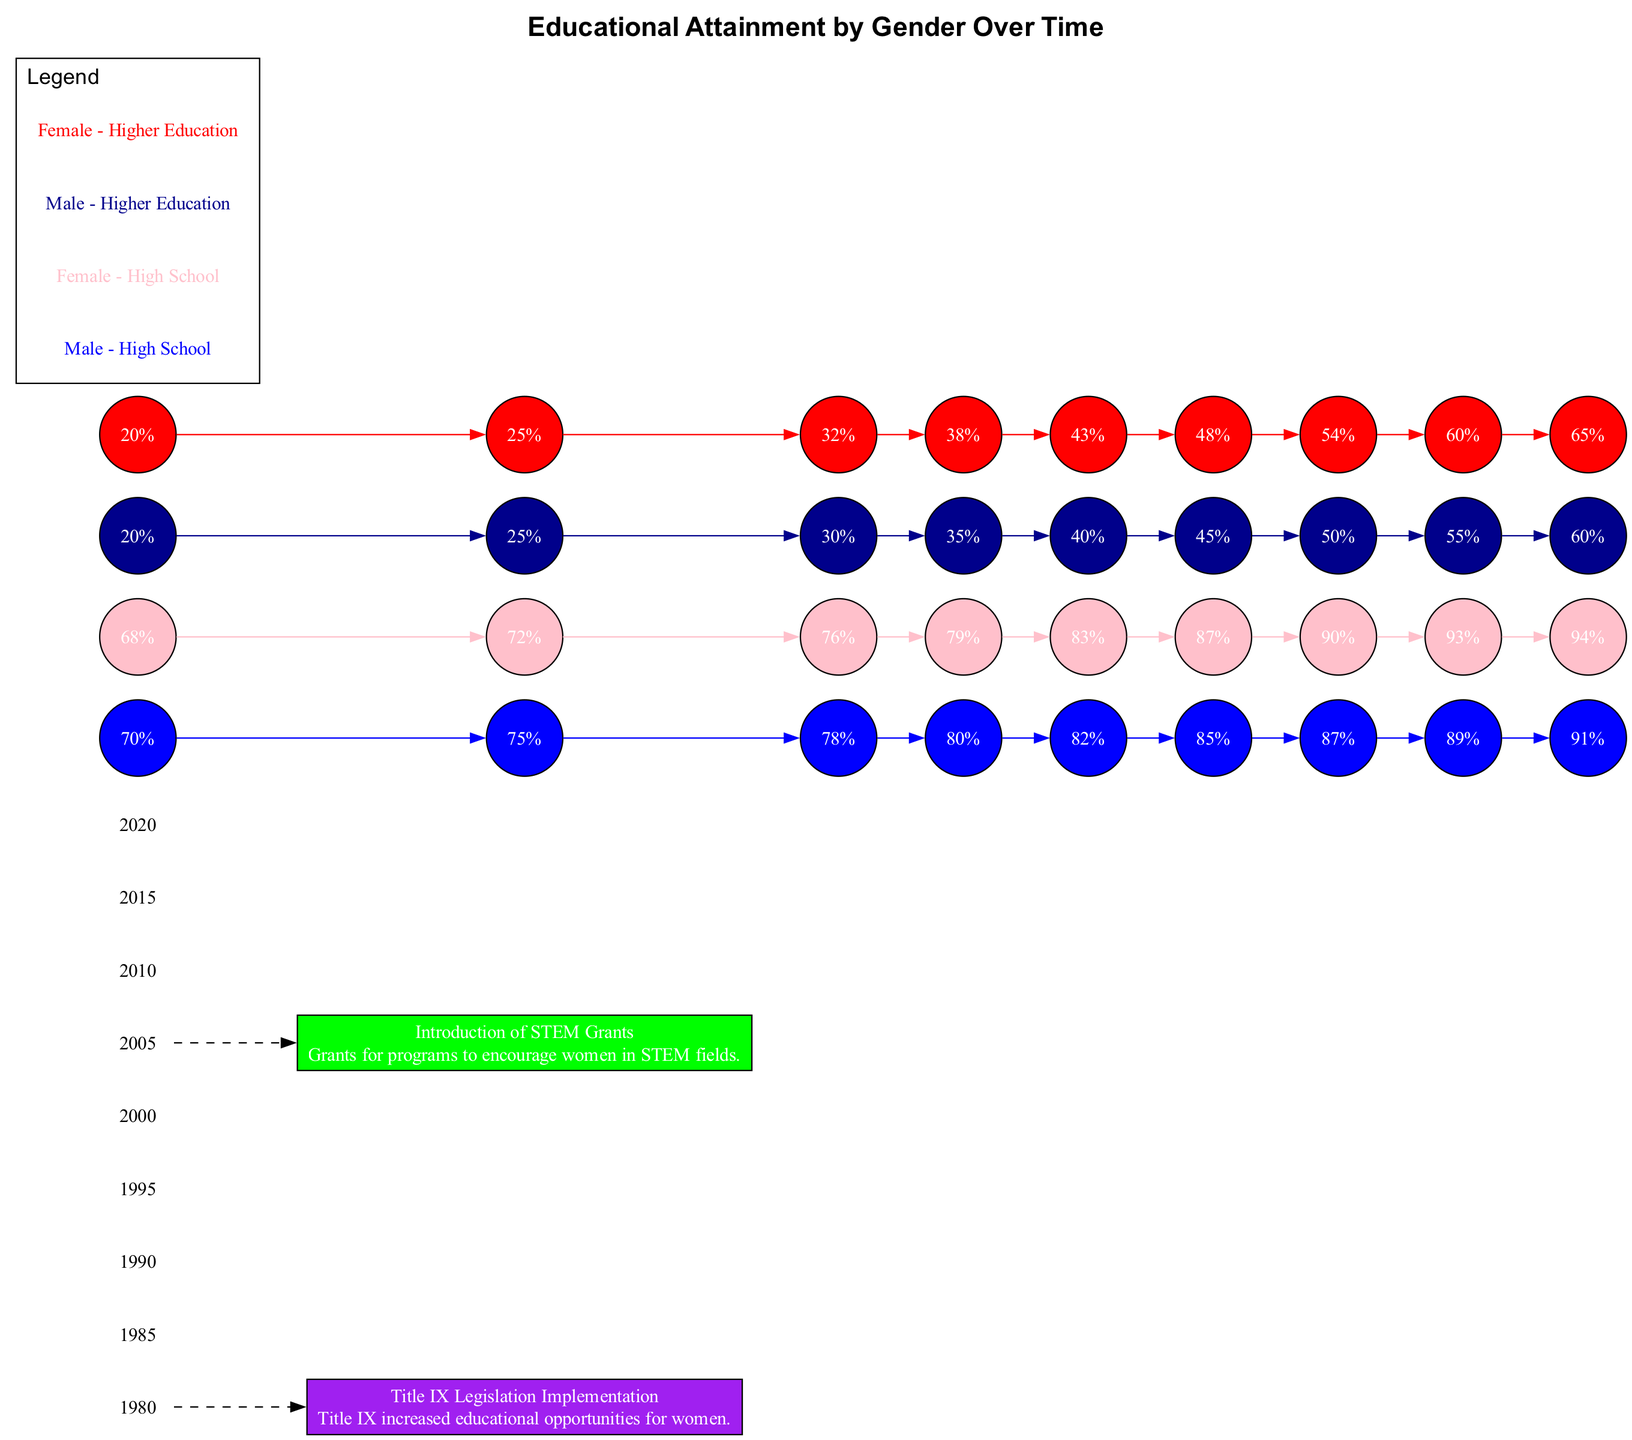What is the graduation rate for females in high school in 2020? The diagram shows that in 2020, the data point for "Female - High School" shows a graduation rate of 94%.
Answer: 94% What is the graduation rate for males in higher education in 2000? The data for 2000 under "Male - Higher Education" indicates a graduation rate of 40%.
Answer: 40% Which gender had a higher graduation rate in higher education in 2015? In 2015, "Female - Higher Education" shows a graduation rate of 60% while "Male - Higher Education" shows 55%. Therefore, females had a higher graduation rate.
Answer: Female What significant educational policy change is indicated in the diagram for 1972? The diagram notes that Title IX legislation was implemented in 1972, which increased educational opportunities for women.
Answer: Title IX What was the graduation rate gap between males and females in high school in 1990? In 1990, the rate for "Male - High School" was 78% and for "Female - High School" it was 76%. The gap is 2%.
Answer: 2% What year marks the introduction of STEM grants in the diagram? The diagram indicates that the introduction of STEM grants occurred in the year 2000.
Answer: 2000 In which decade did the gap between male and female high school graduation rates begin to close significantly? The significant closing of the gap is evident between the years 2000 and 2010, with both genders experiencing higher rates and the difference decreasing.
Answer: 2000s What color represents the graduation rates for females in higher education? On the diagram, the color red is used to represent "Female - Higher Education".
Answer: Red 